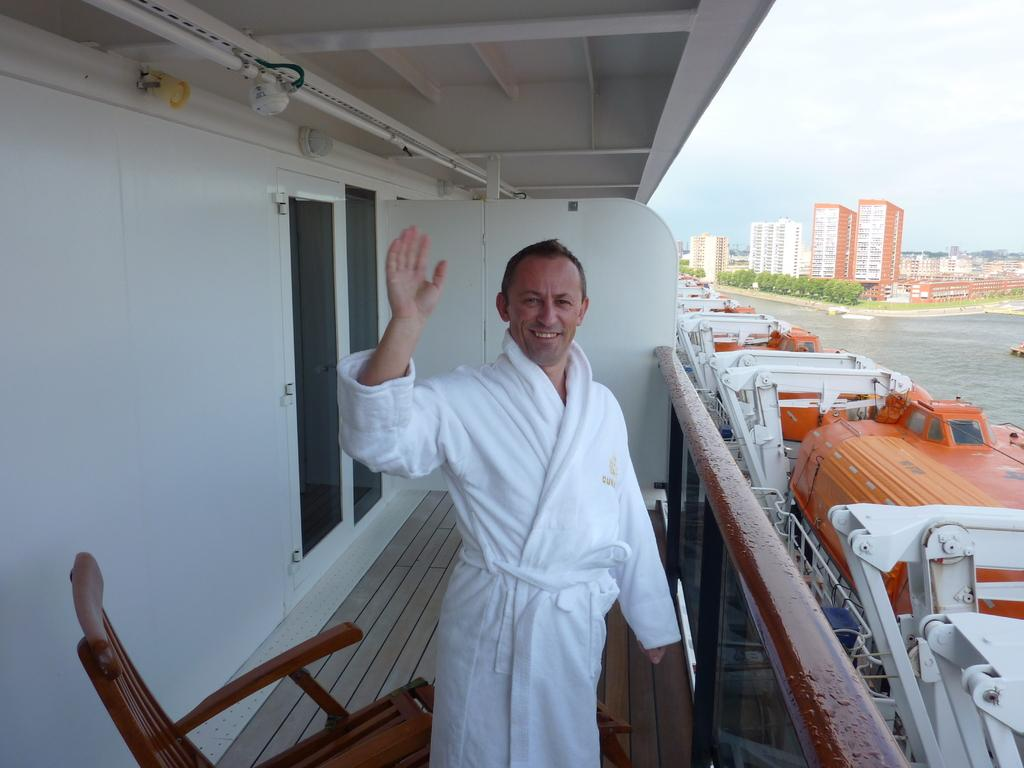What is the main subject of the image? There is a man standing in the image. What can be seen in the background of the image? There are buildings, trees, water, boats, and the sky visible in the background of the image. What is the distribution of the number of fields in the image? There are no fields present in the image, so it is not possible to determine their distribution. 